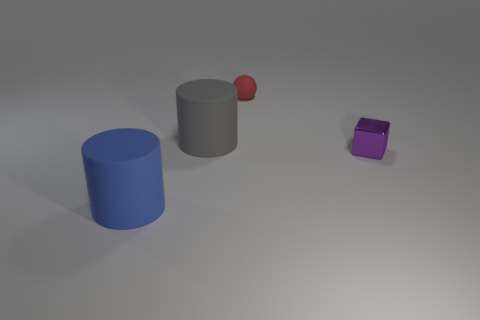There is a large cylinder that is in front of the large thing that is behind the small thing in front of the large gray thing; what is its material?
Your answer should be very brief. Rubber. The sphere has what color?
Give a very brief answer. Red. What number of large objects are either purple metallic objects or rubber things?
Give a very brief answer. 2. Does the tiny thing that is right of the tiny red rubber object have the same material as the big object that is behind the blue matte object?
Your answer should be compact. No. Is there a green shiny cylinder?
Give a very brief answer. No. Is the number of small shiny objects in front of the purple object greater than the number of rubber things on the right side of the red ball?
Provide a short and direct response. No. There is another big thing that is the same shape as the blue matte thing; what is it made of?
Your answer should be very brief. Rubber. Is there anything else that is the same size as the purple block?
Ensure brevity in your answer.  Yes. There is a big object that is in front of the big gray matte object; is it the same color as the object to the right of the rubber sphere?
Your response must be concise. No. What shape is the metallic thing?
Your answer should be compact. Cube. 